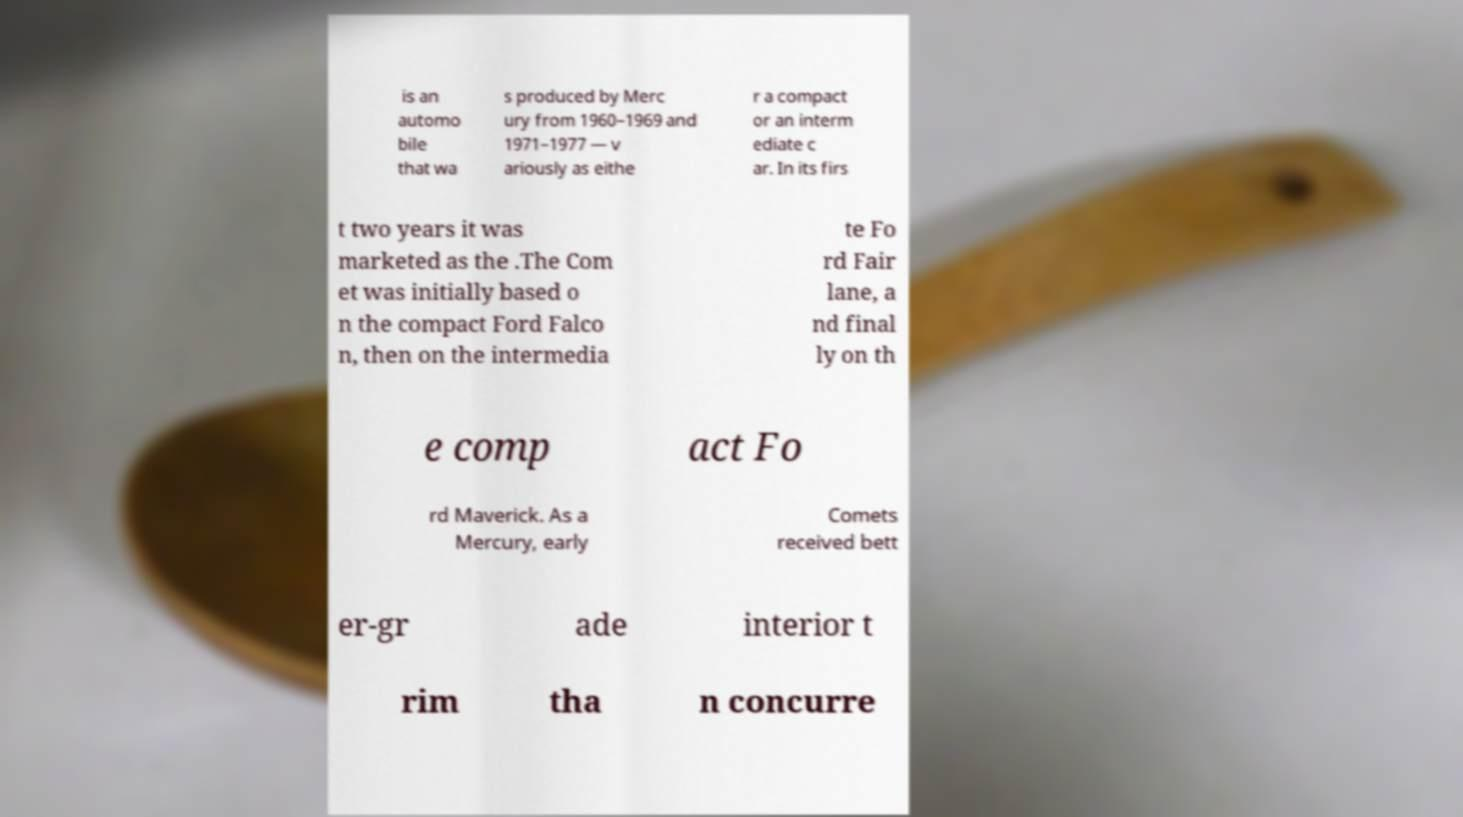Could you extract and type out the text from this image? is an automo bile that wa s produced by Merc ury from 1960–1969 and 1971–1977 — v ariously as eithe r a compact or an interm ediate c ar. In its firs t two years it was marketed as the .The Com et was initially based o n the compact Ford Falco n, then on the intermedia te Fo rd Fair lane, a nd final ly on th e comp act Fo rd Maverick. As a Mercury, early Comets received bett er-gr ade interior t rim tha n concurre 